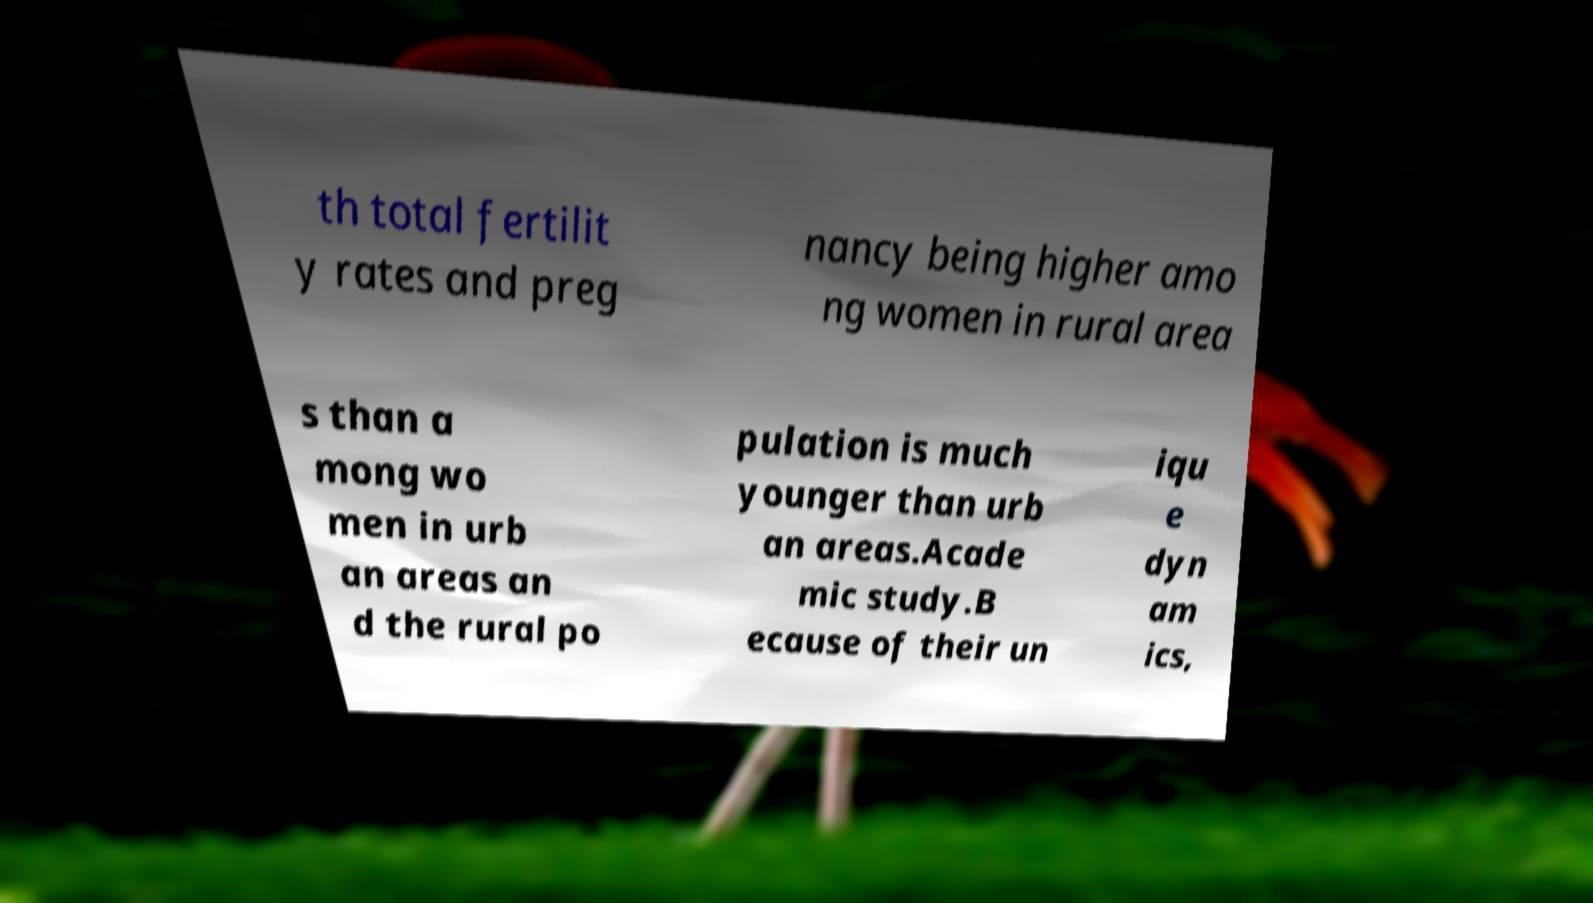Please read and relay the text visible in this image. What does it say? th total fertilit y rates and preg nancy being higher amo ng women in rural area s than a mong wo men in urb an areas an d the rural po pulation is much younger than urb an areas.Acade mic study.B ecause of their un iqu e dyn am ics, 